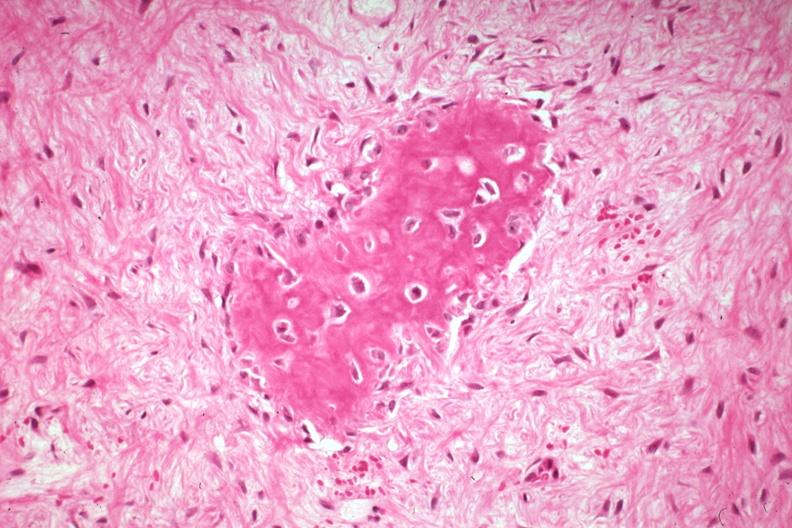what does this image show?
Answer the question using a single word or phrase. High excessive fibrous callus in a non-union with area of osteoid deposition excellent example 